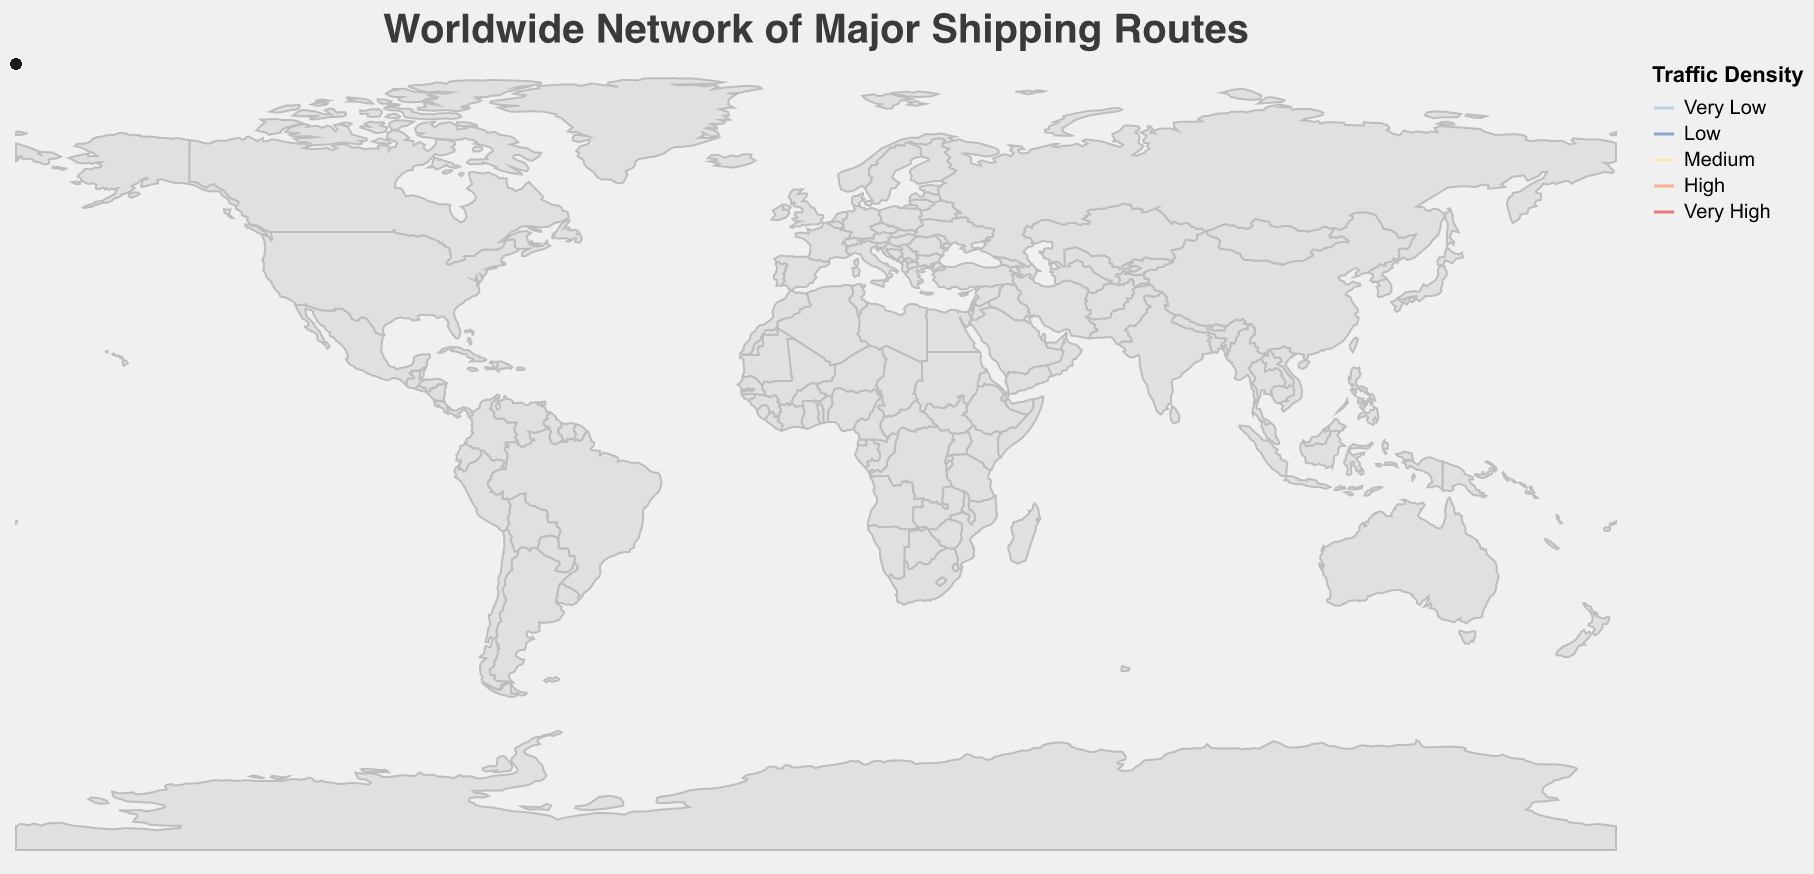What is the title of the figure? The title is typically displayed at the top of the figure in a larger font size. By observing the top section of the figure, we can identify the given title.
Answer: Worldwide Network of Major Shipping Routes Which route has the highest traffic density? By examining the colors and the width of the lines, we can identify that the routes with the darkest red color and thickest lines indicate the highest traffic density.
Answer: Suez Canal and Strait of Malacca What are the start and end ports for the Panama Canal route? The start and end ports are usually indicated along the line representing the route. We need to locate the line labeled "Panama Canal" and find its start and end points.
Answer: Busan and Miami How many routes have a traffic density categorized as "Very Low"? We identify the lines that correspond to "Very Low" traffic density. These lines would be the thinnest and colored in light blue. Counting these lines gives us the answer.
Answer: 4 Which route involves the shortest distance between start and end ports? The route with the shortest distance would be the one with the shortest line between the start and end points on the map. By visually inspecting the lengths of the lines, we can determine this.
Answer: Strait of Gibraltar What is the average traffic density of the following routes: Trans-Atlantic, Cape of Good Hope, and Gulf of Aden? We first identify the traffic density for each of these routes: Medium, Medium, and Medium, respectively. Averaging these identical values will yield the same result.
Answer: Medium Which traffic density category is most frequently observed among the routes? By examining all lines and tallying each traffic density category, we can determine which one appears most frequently. We compare the counts of each category (Very Low, Low, Medium, High, Very High) for the answer.
Answer: Medium Which route passes through the start port of Odessa? We locate Odessa on the map and identify which line (route) originates from this port.
Answer: Bosphorus Strait 